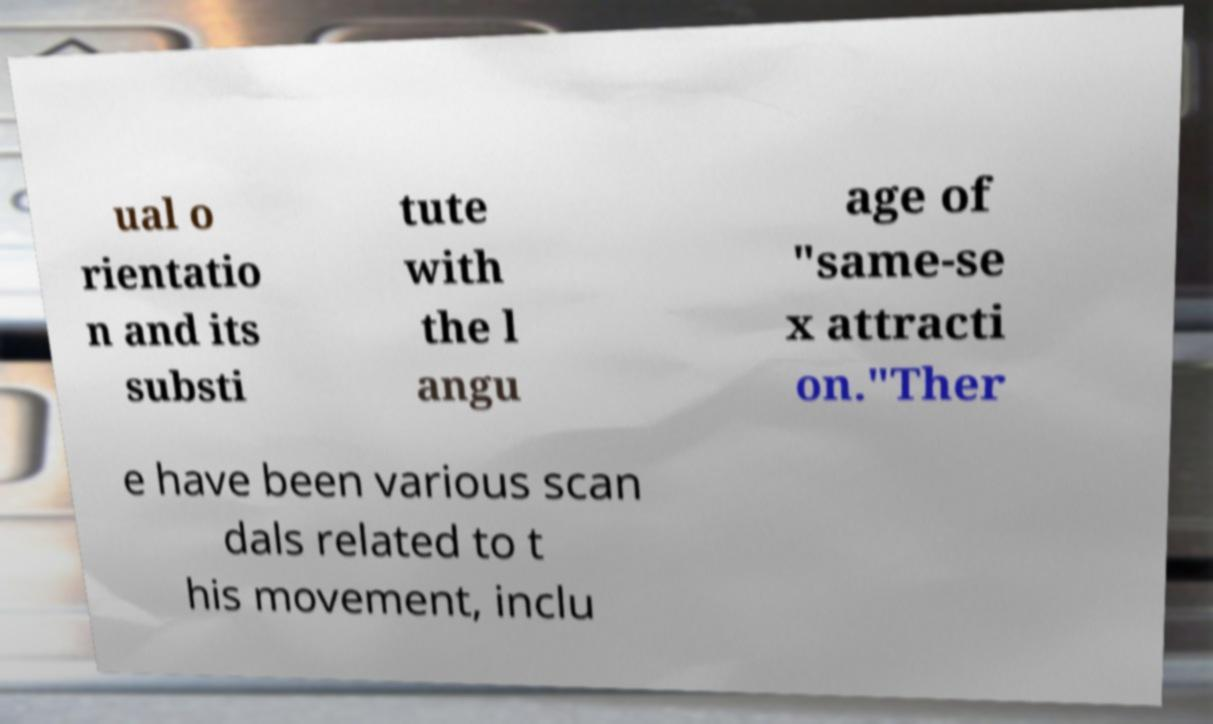Please identify and transcribe the text found in this image. ual o rientatio n and its substi tute with the l angu age of "same-se x attracti on."Ther e have been various scan dals related to t his movement, inclu 